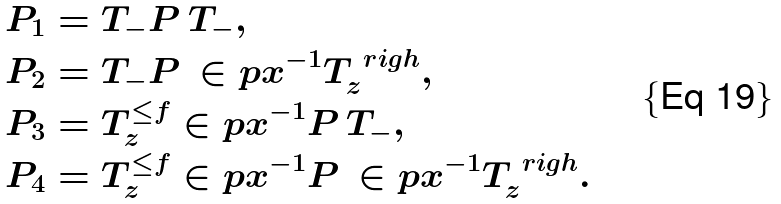Convert formula to latex. <formula><loc_0><loc_0><loc_500><loc_500>P _ { 1 } & = T _ { - } P \, T _ { - } , \\ P _ { 2 } & = T _ { - } P \, \in p { x } ^ { - 1 } T _ { z } ^ { \ r i g h } , \\ P _ { 3 } & = T _ { z } ^ { \leq f } \in p { x } ^ { - 1 } P \, T _ { - } , \\ P _ { 4 } & = T _ { z } ^ { \leq f } \in p { x } ^ { - 1 } P \, \in p { x } ^ { - 1 } T _ { z } ^ { \ r i g h } .</formula> 